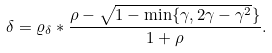<formula> <loc_0><loc_0><loc_500><loc_500>\delta = \varrho _ { \delta } * \frac { \rho - \sqrt { 1 - \min \{ \gamma , 2 \gamma - \gamma ^ { 2 } } \} } { 1 + \rho } .</formula> 